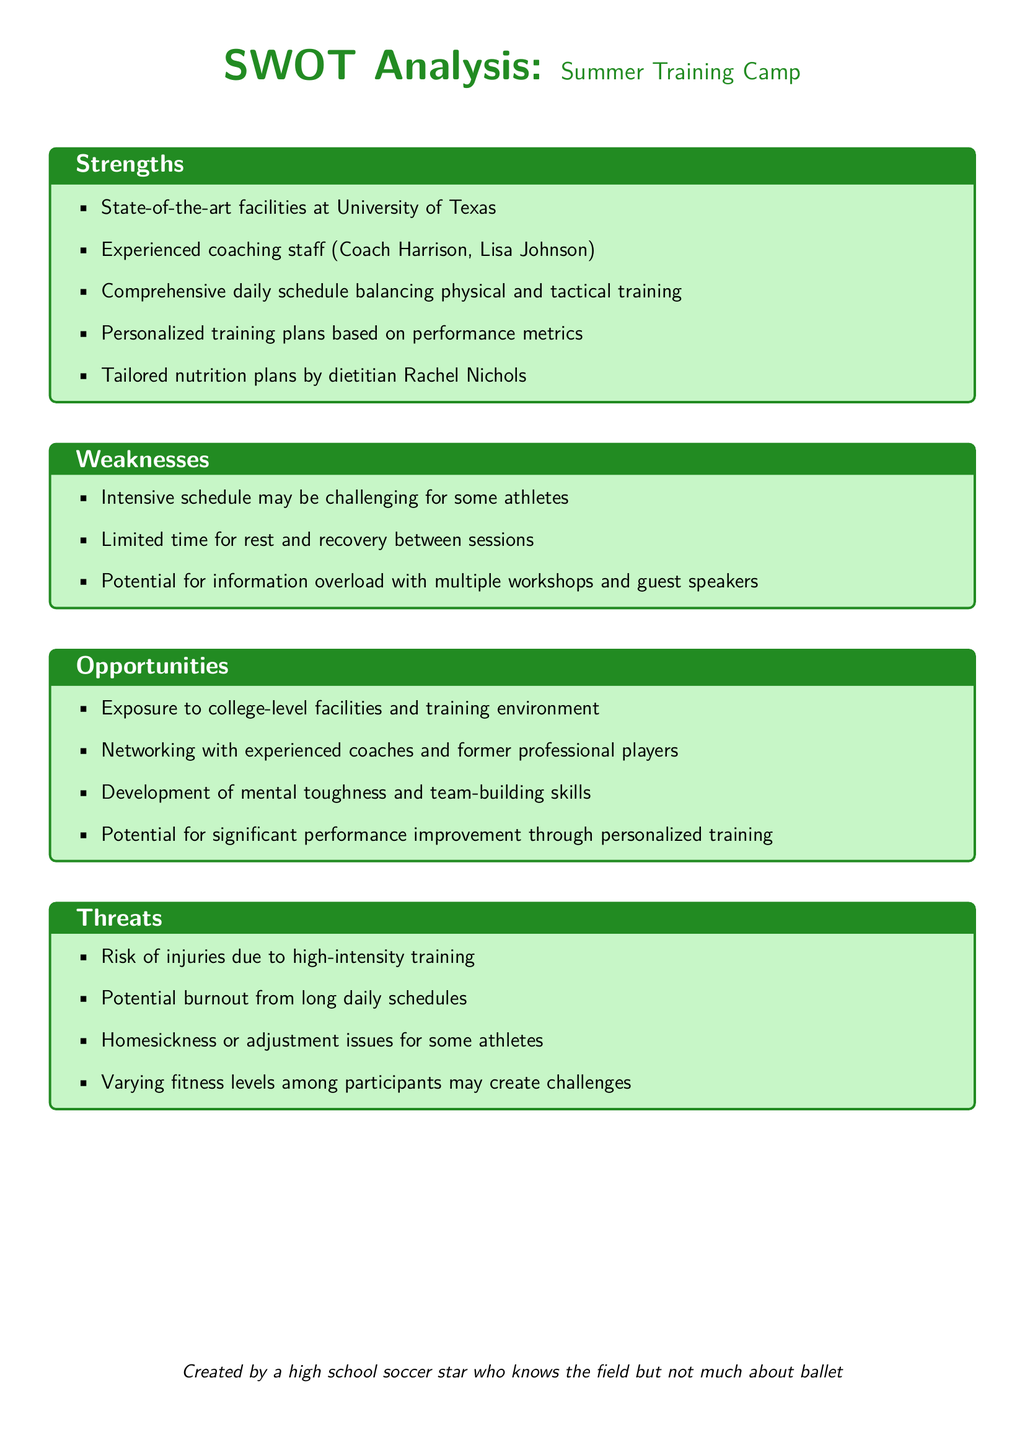What are the state-of-the-art facilities? The document references the facilities located at the University of Texas as state-of-the-art.
Answer: University of Texas Who is the dietitian mentioned? The document lists Rachel Nichols as the dietitian providing tailored nutrition plans.
Answer: Rachel Nichols What is one potential risk associated with high-intensity training? The document states that a risk of injuries can arise from high-intensity training.
Answer: Injuries What is a negative aspect of the intensive schedule? The document notes that the intensive schedule may be challenging for some athletes.
Answer: Challenging What is one opportunity for networking? The document indicates networking opportunities with experienced coaches and former professional players.
Answer: Experienced coaches and former professional players How many coaching staff members are mentioned? The document lists two coaching staff members: Coach Harrison and Lisa Johnson.
Answer: Two What skill might development aid the athletes? The document describes the development of mental toughness as a potential benefit for athletes.
Answer: Mental toughness What issue might some athletes face related to adjustment? The document mentions homesickness or adjustment issues as potential challenges for some athletes.
Answer: Homesickness or adjustment issues 